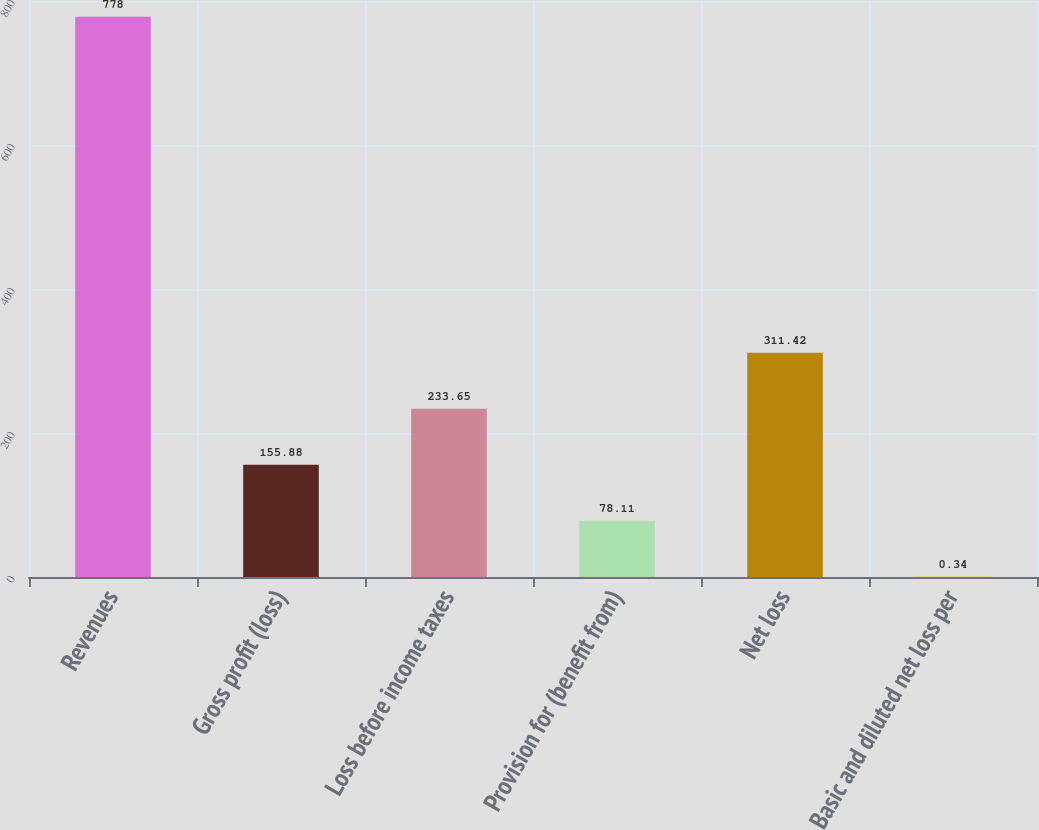Convert chart to OTSL. <chart><loc_0><loc_0><loc_500><loc_500><bar_chart><fcel>Revenues<fcel>Gross profit (loss)<fcel>Loss before income taxes<fcel>Provision for (benefit from)<fcel>Net loss<fcel>Basic and diluted net loss per<nl><fcel>778<fcel>155.88<fcel>233.65<fcel>78.11<fcel>311.42<fcel>0.34<nl></chart> 